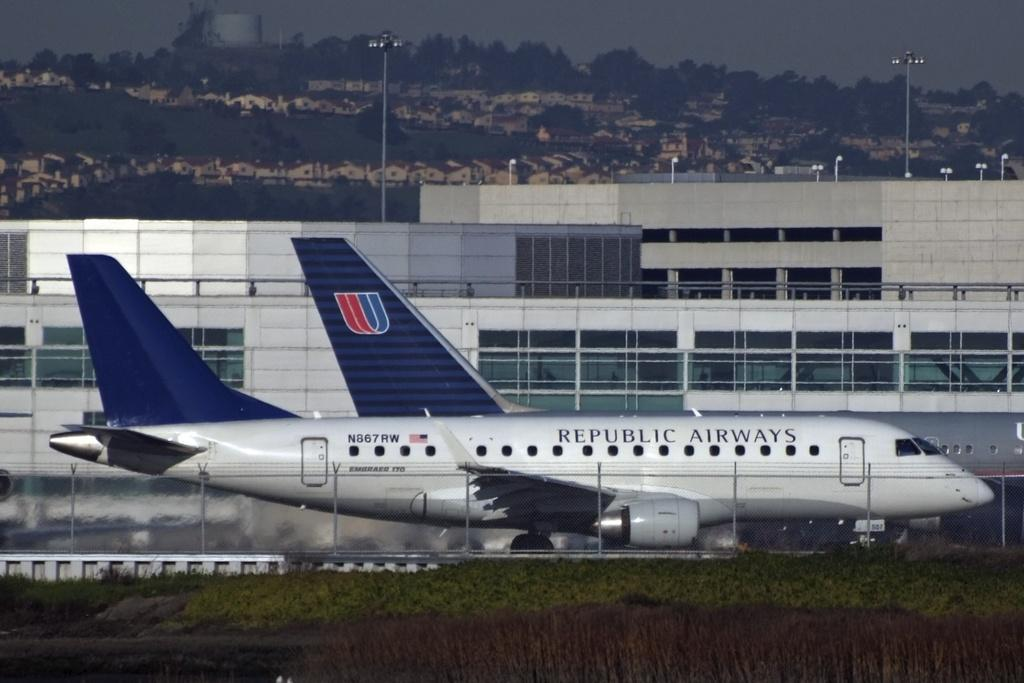What type of vegetation is present in the image? There is grass in the image. What is the main mode of transportation visible in the image? There is an airplane in the image. What type of structure can be seen in the image? There is a building in the image. What are the light sources in the image? There are light poles in the image. What can be seen in the background of the image? There are trees and the sky visible in the background of the image. Can you see a needle being used to sew in the image? There is no needle or sewing activity present in the image. Is there a dog visible in the image? There is no dog present in the image. 